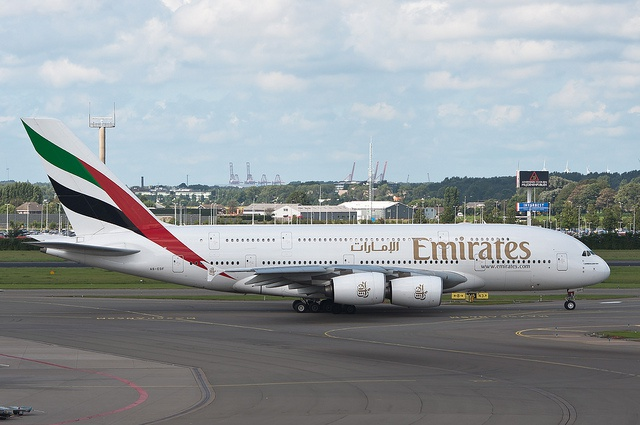Describe the objects in this image and their specific colors. I can see a airplane in lightgray, darkgray, black, and gray tones in this image. 